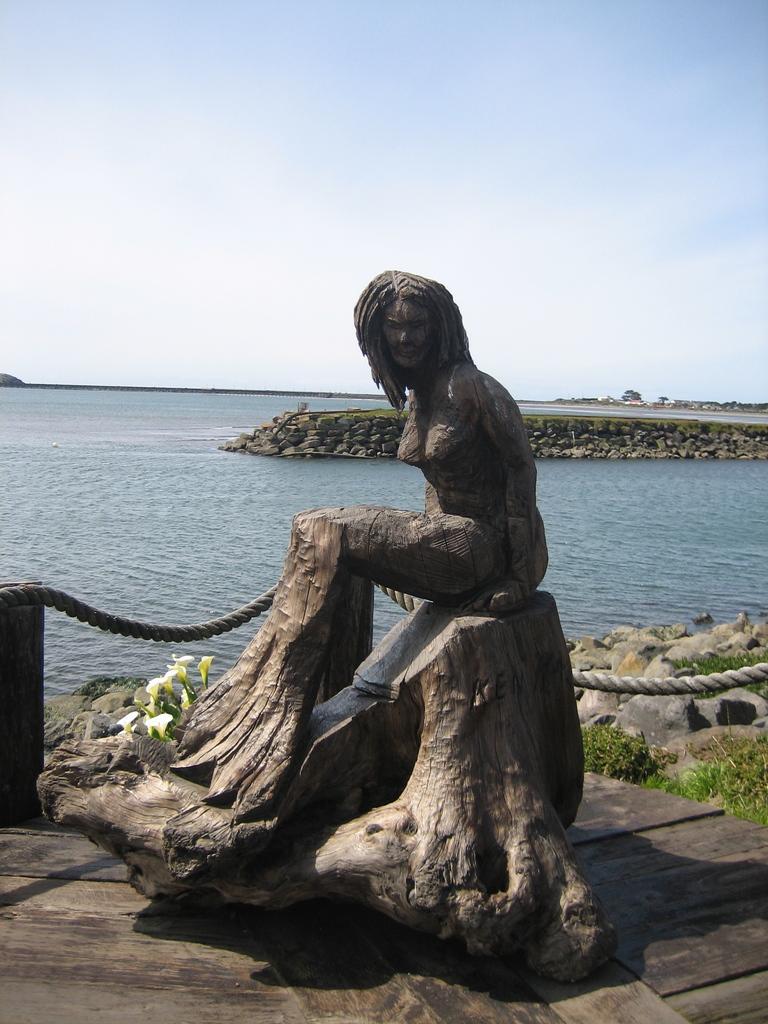Can you describe this image briefly? This picture shows a wooden carved statue and we see plants and flowers and we see water and a rope fence and a cloudy Sky. 